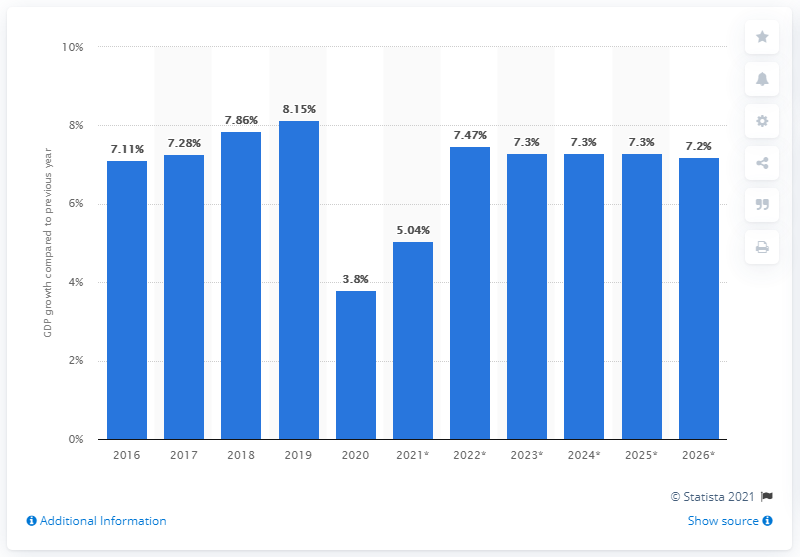List a handful of essential elements in this visual. In 2020, the real Gross Domestic Product (GDP) of Bangladesh increased by 3.8%. 